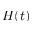Convert formula to latex. <formula><loc_0><loc_0><loc_500><loc_500>H ( t )</formula> 